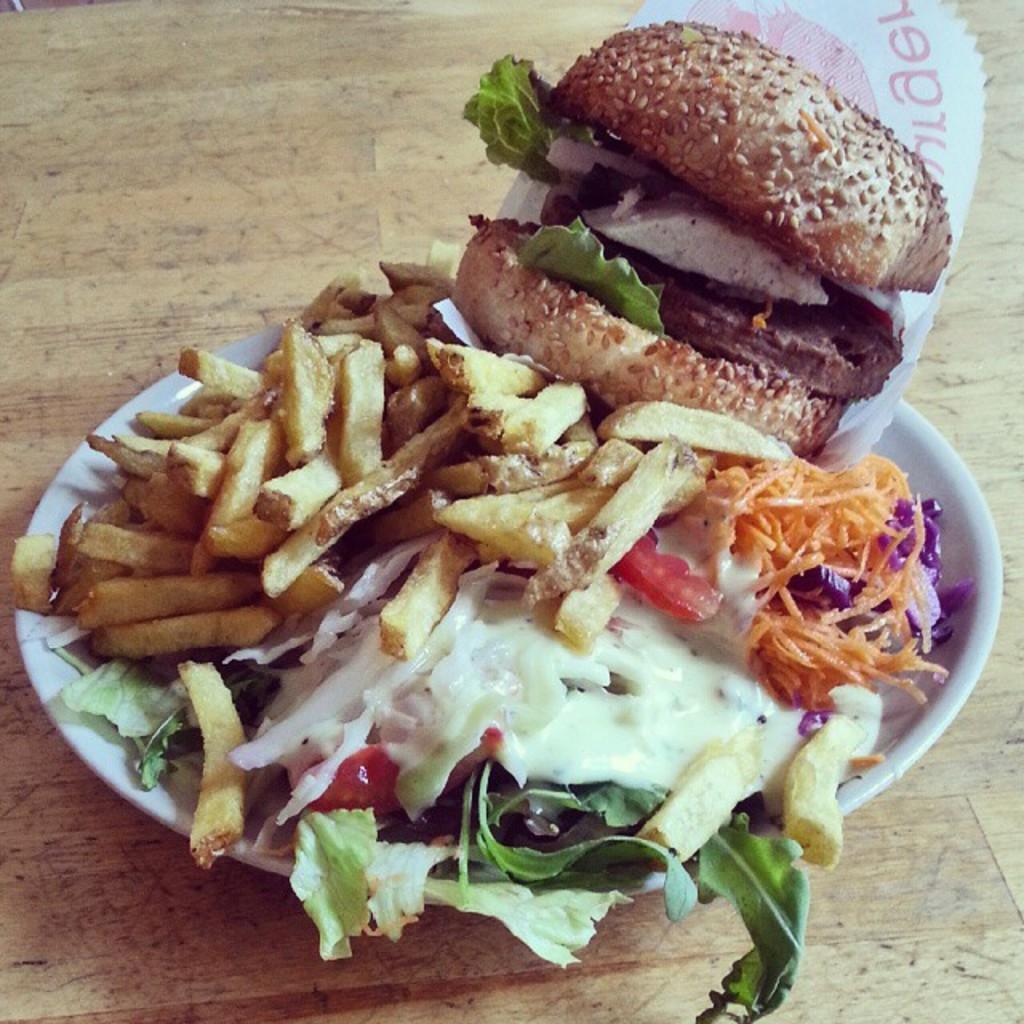What is on the serving plate in the image? The serving plate contains food. Where is the serving plate located in the image? The serving plate is placed on a table. What type of wire is used to hold the birthday cake on the serving plate? There is no birthday cake or wire present in the image. 